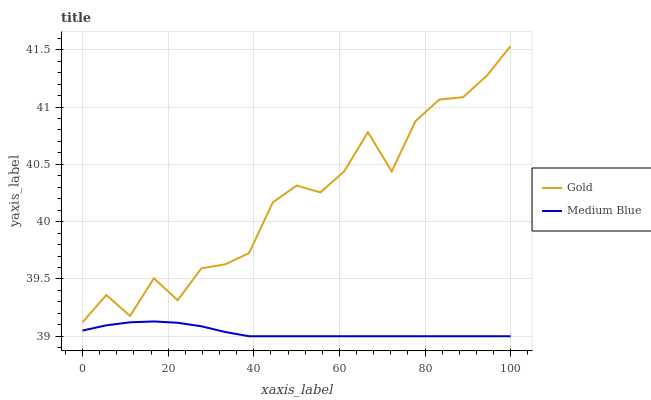Does Medium Blue have the minimum area under the curve?
Answer yes or no. Yes. Does Gold have the maximum area under the curve?
Answer yes or no. Yes. Does Gold have the minimum area under the curve?
Answer yes or no. No. Is Medium Blue the smoothest?
Answer yes or no. Yes. Is Gold the roughest?
Answer yes or no. Yes. Is Gold the smoothest?
Answer yes or no. No. Does Gold have the lowest value?
Answer yes or no. No. Does Gold have the highest value?
Answer yes or no. Yes. Is Medium Blue less than Gold?
Answer yes or no. Yes. Is Gold greater than Medium Blue?
Answer yes or no. Yes. Does Medium Blue intersect Gold?
Answer yes or no. No. 